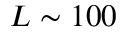<formula> <loc_0><loc_0><loc_500><loc_500>L \sim 1 0 0</formula> 